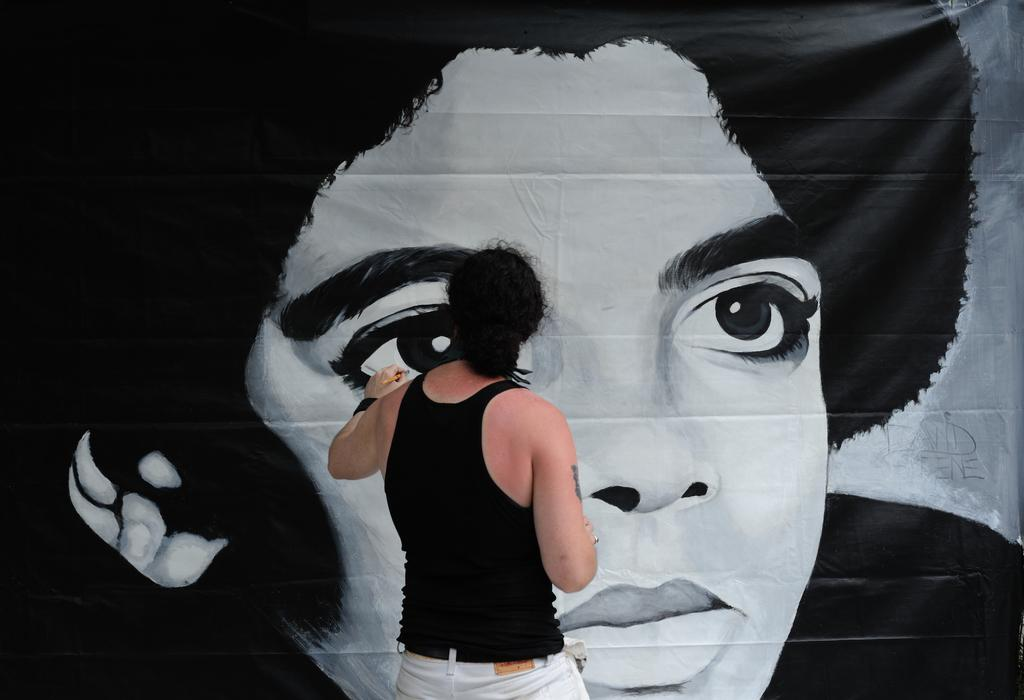Who is present in the image? There is a man in the image. What is the man wearing? The man is wearing a black tank top. What is the man holding in the image? The man is holding a brush. Can you describe the painting in the image? There is a painting on an item in the image. What type of tray is the man using to point at the end of the painting? There is no tray or pointing gesture in the image, and the painting does not have an end as it is a two-dimensional representation. 